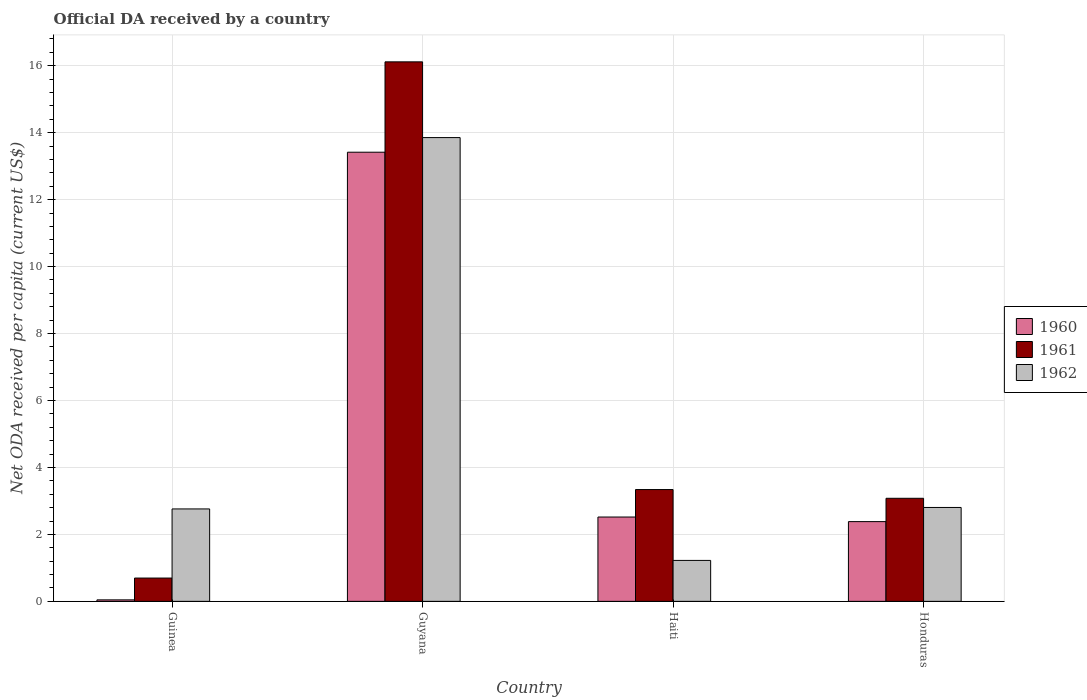How many different coloured bars are there?
Your answer should be compact. 3. How many groups of bars are there?
Give a very brief answer. 4. Are the number of bars per tick equal to the number of legend labels?
Provide a short and direct response. Yes. How many bars are there on the 1st tick from the left?
Your answer should be compact. 3. How many bars are there on the 3rd tick from the right?
Keep it short and to the point. 3. What is the label of the 1st group of bars from the left?
Your response must be concise. Guinea. What is the ODA received in in 1960 in Haiti?
Give a very brief answer. 2.52. Across all countries, what is the maximum ODA received in in 1960?
Your answer should be very brief. 13.42. Across all countries, what is the minimum ODA received in in 1962?
Keep it short and to the point. 1.22. In which country was the ODA received in in 1960 maximum?
Offer a terse response. Guyana. In which country was the ODA received in in 1961 minimum?
Ensure brevity in your answer.  Guinea. What is the total ODA received in in 1961 in the graph?
Your answer should be very brief. 23.23. What is the difference between the ODA received in in 1962 in Guyana and that in Honduras?
Offer a very short reply. 11.05. What is the difference between the ODA received in in 1962 in Guyana and the ODA received in in 1961 in Honduras?
Offer a terse response. 10.78. What is the average ODA received in in 1962 per country?
Your answer should be very brief. 5.16. What is the difference between the ODA received in of/in 1962 and ODA received in of/in 1960 in Honduras?
Your answer should be very brief. 0.42. What is the ratio of the ODA received in in 1961 in Guyana to that in Haiti?
Ensure brevity in your answer.  4.83. Is the ODA received in in 1961 in Guinea less than that in Guyana?
Ensure brevity in your answer.  Yes. Is the difference between the ODA received in in 1962 in Haiti and Honduras greater than the difference between the ODA received in in 1960 in Haiti and Honduras?
Provide a succinct answer. No. What is the difference between the highest and the second highest ODA received in in 1961?
Make the answer very short. 12.78. What is the difference between the highest and the lowest ODA received in in 1962?
Offer a terse response. 12.63. Is the sum of the ODA received in in 1960 in Guinea and Guyana greater than the maximum ODA received in in 1962 across all countries?
Keep it short and to the point. No. What does the 2nd bar from the left in Haiti represents?
Provide a succinct answer. 1961. What does the 1st bar from the right in Honduras represents?
Provide a short and direct response. 1962. Are all the bars in the graph horizontal?
Offer a terse response. No. What is the difference between two consecutive major ticks on the Y-axis?
Ensure brevity in your answer.  2. Are the values on the major ticks of Y-axis written in scientific E-notation?
Provide a short and direct response. No. Does the graph contain any zero values?
Offer a very short reply. No. Where does the legend appear in the graph?
Offer a very short reply. Center right. What is the title of the graph?
Your answer should be compact. Official DA received by a country. Does "1984" appear as one of the legend labels in the graph?
Your response must be concise. No. What is the label or title of the Y-axis?
Provide a succinct answer. Net ODA received per capita (current US$). What is the Net ODA received per capita (current US$) in 1960 in Guinea?
Provide a short and direct response. 0.04. What is the Net ODA received per capita (current US$) of 1961 in Guinea?
Give a very brief answer. 0.7. What is the Net ODA received per capita (current US$) in 1962 in Guinea?
Keep it short and to the point. 2.76. What is the Net ODA received per capita (current US$) of 1960 in Guyana?
Your answer should be very brief. 13.42. What is the Net ODA received per capita (current US$) of 1961 in Guyana?
Your response must be concise. 16.12. What is the Net ODA received per capita (current US$) of 1962 in Guyana?
Your answer should be compact. 13.85. What is the Net ODA received per capita (current US$) of 1960 in Haiti?
Your answer should be compact. 2.52. What is the Net ODA received per capita (current US$) in 1961 in Haiti?
Ensure brevity in your answer.  3.34. What is the Net ODA received per capita (current US$) in 1962 in Haiti?
Your response must be concise. 1.22. What is the Net ODA received per capita (current US$) in 1960 in Honduras?
Your answer should be very brief. 2.38. What is the Net ODA received per capita (current US$) in 1961 in Honduras?
Give a very brief answer. 3.08. What is the Net ODA received per capita (current US$) of 1962 in Honduras?
Provide a succinct answer. 2.8. Across all countries, what is the maximum Net ODA received per capita (current US$) of 1960?
Give a very brief answer. 13.42. Across all countries, what is the maximum Net ODA received per capita (current US$) in 1961?
Your answer should be compact. 16.12. Across all countries, what is the maximum Net ODA received per capita (current US$) in 1962?
Your response must be concise. 13.85. Across all countries, what is the minimum Net ODA received per capita (current US$) of 1960?
Keep it short and to the point. 0.04. Across all countries, what is the minimum Net ODA received per capita (current US$) in 1961?
Offer a terse response. 0.7. Across all countries, what is the minimum Net ODA received per capita (current US$) in 1962?
Keep it short and to the point. 1.22. What is the total Net ODA received per capita (current US$) in 1960 in the graph?
Make the answer very short. 18.36. What is the total Net ODA received per capita (current US$) in 1961 in the graph?
Keep it short and to the point. 23.23. What is the total Net ODA received per capita (current US$) of 1962 in the graph?
Your response must be concise. 20.64. What is the difference between the Net ODA received per capita (current US$) of 1960 in Guinea and that in Guyana?
Keep it short and to the point. -13.37. What is the difference between the Net ODA received per capita (current US$) in 1961 in Guinea and that in Guyana?
Offer a terse response. -15.42. What is the difference between the Net ODA received per capita (current US$) in 1962 in Guinea and that in Guyana?
Provide a succinct answer. -11.09. What is the difference between the Net ODA received per capita (current US$) in 1960 in Guinea and that in Haiti?
Offer a very short reply. -2.47. What is the difference between the Net ODA received per capita (current US$) in 1961 in Guinea and that in Haiti?
Provide a short and direct response. -2.64. What is the difference between the Net ODA received per capita (current US$) in 1962 in Guinea and that in Haiti?
Your answer should be compact. 1.54. What is the difference between the Net ODA received per capita (current US$) of 1960 in Guinea and that in Honduras?
Give a very brief answer. -2.34. What is the difference between the Net ODA received per capita (current US$) in 1961 in Guinea and that in Honduras?
Your response must be concise. -2.38. What is the difference between the Net ODA received per capita (current US$) in 1962 in Guinea and that in Honduras?
Keep it short and to the point. -0.04. What is the difference between the Net ODA received per capita (current US$) of 1960 in Guyana and that in Haiti?
Your response must be concise. 10.9. What is the difference between the Net ODA received per capita (current US$) in 1961 in Guyana and that in Haiti?
Keep it short and to the point. 12.78. What is the difference between the Net ODA received per capita (current US$) of 1962 in Guyana and that in Haiti?
Provide a short and direct response. 12.63. What is the difference between the Net ODA received per capita (current US$) in 1960 in Guyana and that in Honduras?
Provide a short and direct response. 11.03. What is the difference between the Net ODA received per capita (current US$) in 1961 in Guyana and that in Honduras?
Make the answer very short. 13.04. What is the difference between the Net ODA received per capita (current US$) in 1962 in Guyana and that in Honduras?
Offer a very short reply. 11.05. What is the difference between the Net ODA received per capita (current US$) of 1960 in Haiti and that in Honduras?
Give a very brief answer. 0.14. What is the difference between the Net ODA received per capita (current US$) of 1961 in Haiti and that in Honduras?
Your answer should be compact. 0.26. What is the difference between the Net ODA received per capita (current US$) of 1962 in Haiti and that in Honduras?
Offer a terse response. -1.58. What is the difference between the Net ODA received per capita (current US$) in 1960 in Guinea and the Net ODA received per capita (current US$) in 1961 in Guyana?
Your answer should be compact. -16.07. What is the difference between the Net ODA received per capita (current US$) in 1960 in Guinea and the Net ODA received per capita (current US$) in 1962 in Guyana?
Your response must be concise. -13.81. What is the difference between the Net ODA received per capita (current US$) in 1961 in Guinea and the Net ODA received per capita (current US$) in 1962 in Guyana?
Offer a terse response. -13.16. What is the difference between the Net ODA received per capita (current US$) in 1960 in Guinea and the Net ODA received per capita (current US$) in 1961 in Haiti?
Keep it short and to the point. -3.3. What is the difference between the Net ODA received per capita (current US$) of 1960 in Guinea and the Net ODA received per capita (current US$) of 1962 in Haiti?
Make the answer very short. -1.18. What is the difference between the Net ODA received per capita (current US$) of 1961 in Guinea and the Net ODA received per capita (current US$) of 1962 in Haiti?
Your answer should be compact. -0.53. What is the difference between the Net ODA received per capita (current US$) in 1960 in Guinea and the Net ODA received per capita (current US$) in 1961 in Honduras?
Your answer should be compact. -3.03. What is the difference between the Net ODA received per capita (current US$) of 1960 in Guinea and the Net ODA received per capita (current US$) of 1962 in Honduras?
Your answer should be compact. -2.76. What is the difference between the Net ODA received per capita (current US$) in 1961 in Guinea and the Net ODA received per capita (current US$) in 1962 in Honduras?
Give a very brief answer. -2.11. What is the difference between the Net ODA received per capita (current US$) of 1960 in Guyana and the Net ODA received per capita (current US$) of 1961 in Haiti?
Offer a terse response. 10.08. What is the difference between the Net ODA received per capita (current US$) in 1960 in Guyana and the Net ODA received per capita (current US$) in 1962 in Haiti?
Offer a very short reply. 12.19. What is the difference between the Net ODA received per capita (current US$) of 1961 in Guyana and the Net ODA received per capita (current US$) of 1962 in Haiti?
Offer a very short reply. 14.89. What is the difference between the Net ODA received per capita (current US$) of 1960 in Guyana and the Net ODA received per capita (current US$) of 1961 in Honduras?
Keep it short and to the point. 10.34. What is the difference between the Net ODA received per capita (current US$) of 1960 in Guyana and the Net ODA received per capita (current US$) of 1962 in Honduras?
Offer a terse response. 10.61. What is the difference between the Net ODA received per capita (current US$) of 1961 in Guyana and the Net ODA received per capita (current US$) of 1962 in Honduras?
Ensure brevity in your answer.  13.31. What is the difference between the Net ODA received per capita (current US$) in 1960 in Haiti and the Net ODA received per capita (current US$) in 1961 in Honduras?
Make the answer very short. -0.56. What is the difference between the Net ODA received per capita (current US$) in 1960 in Haiti and the Net ODA received per capita (current US$) in 1962 in Honduras?
Make the answer very short. -0.29. What is the difference between the Net ODA received per capita (current US$) of 1961 in Haiti and the Net ODA received per capita (current US$) of 1962 in Honduras?
Your answer should be very brief. 0.54. What is the average Net ODA received per capita (current US$) of 1960 per country?
Provide a short and direct response. 4.59. What is the average Net ODA received per capita (current US$) in 1961 per country?
Provide a short and direct response. 5.81. What is the average Net ODA received per capita (current US$) of 1962 per country?
Offer a very short reply. 5.16. What is the difference between the Net ODA received per capita (current US$) of 1960 and Net ODA received per capita (current US$) of 1961 in Guinea?
Offer a very short reply. -0.65. What is the difference between the Net ODA received per capita (current US$) of 1960 and Net ODA received per capita (current US$) of 1962 in Guinea?
Keep it short and to the point. -2.72. What is the difference between the Net ODA received per capita (current US$) in 1961 and Net ODA received per capita (current US$) in 1962 in Guinea?
Give a very brief answer. -2.06. What is the difference between the Net ODA received per capita (current US$) of 1960 and Net ODA received per capita (current US$) of 1961 in Guyana?
Your answer should be compact. -2.7. What is the difference between the Net ODA received per capita (current US$) in 1960 and Net ODA received per capita (current US$) in 1962 in Guyana?
Give a very brief answer. -0.44. What is the difference between the Net ODA received per capita (current US$) of 1961 and Net ODA received per capita (current US$) of 1962 in Guyana?
Give a very brief answer. 2.26. What is the difference between the Net ODA received per capita (current US$) in 1960 and Net ODA received per capita (current US$) in 1961 in Haiti?
Offer a very short reply. -0.82. What is the difference between the Net ODA received per capita (current US$) of 1960 and Net ODA received per capita (current US$) of 1962 in Haiti?
Provide a succinct answer. 1.3. What is the difference between the Net ODA received per capita (current US$) of 1961 and Net ODA received per capita (current US$) of 1962 in Haiti?
Offer a very short reply. 2.12. What is the difference between the Net ODA received per capita (current US$) in 1960 and Net ODA received per capita (current US$) in 1961 in Honduras?
Offer a very short reply. -0.7. What is the difference between the Net ODA received per capita (current US$) of 1960 and Net ODA received per capita (current US$) of 1962 in Honduras?
Provide a succinct answer. -0.42. What is the difference between the Net ODA received per capita (current US$) in 1961 and Net ODA received per capita (current US$) in 1962 in Honduras?
Give a very brief answer. 0.27. What is the ratio of the Net ODA received per capita (current US$) of 1960 in Guinea to that in Guyana?
Your response must be concise. 0. What is the ratio of the Net ODA received per capita (current US$) in 1961 in Guinea to that in Guyana?
Provide a short and direct response. 0.04. What is the ratio of the Net ODA received per capita (current US$) of 1962 in Guinea to that in Guyana?
Keep it short and to the point. 0.2. What is the ratio of the Net ODA received per capita (current US$) of 1960 in Guinea to that in Haiti?
Your answer should be very brief. 0.02. What is the ratio of the Net ODA received per capita (current US$) in 1961 in Guinea to that in Haiti?
Provide a succinct answer. 0.21. What is the ratio of the Net ODA received per capita (current US$) in 1962 in Guinea to that in Haiti?
Give a very brief answer. 2.26. What is the ratio of the Net ODA received per capita (current US$) of 1960 in Guinea to that in Honduras?
Keep it short and to the point. 0.02. What is the ratio of the Net ODA received per capita (current US$) of 1961 in Guinea to that in Honduras?
Offer a very short reply. 0.23. What is the ratio of the Net ODA received per capita (current US$) in 1962 in Guinea to that in Honduras?
Offer a terse response. 0.98. What is the ratio of the Net ODA received per capita (current US$) in 1960 in Guyana to that in Haiti?
Your answer should be very brief. 5.33. What is the ratio of the Net ODA received per capita (current US$) in 1961 in Guyana to that in Haiti?
Offer a terse response. 4.83. What is the ratio of the Net ODA received per capita (current US$) in 1962 in Guyana to that in Haiti?
Provide a short and direct response. 11.33. What is the ratio of the Net ODA received per capita (current US$) of 1960 in Guyana to that in Honduras?
Ensure brevity in your answer.  5.63. What is the ratio of the Net ODA received per capita (current US$) in 1961 in Guyana to that in Honduras?
Ensure brevity in your answer.  5.23. What is the ratio of the Net ODA received per capita (current US$) of 1962 in Guyana to that in Honduras?
Your answer should be very brief. 4.94. What is the ratio of the Net ODA received per capita (current US$) in 1960 in Haiti to that in Honduras?
Offer a terse response. 1.06. What is the ratio of the Net ODA received per capita (current US$) of 1961 in Haiti to that in Honduras?
Provide a short and direct response. 1.08. What is the ratio of the Net ODA received per capita (current US$) in 1962 in Haiti to that in Honduras?
Ensure brevity in your answer.  0.44. What is the difference between the highest and the second highest Net ODA received per capita (current US$) in 1960?
Ensure brevity in your answer.  10.9. What is the difference between the highest and the second highest Net ODA received per capita (current US$) of 1961?
Provide a succinct answer. 12.78. What is the difference between the highest and the second highest Net ODA received per capita (current US$) in 1962?
Offer a terse response. 11.05. What is the difference between the highest and the lowest Net ODA received per capita (current US$) of 1960?
Provide a short and direct response. 13.37. What is the difference between the highest and the lowest Net ODA received per capita (current US$) of 1961?
Give a very brief answer. 15.42. What is the difference between the highest and the lowest Net ODA received per capita (current US$) in 1962?
Your answer should be compact. 12.63. 